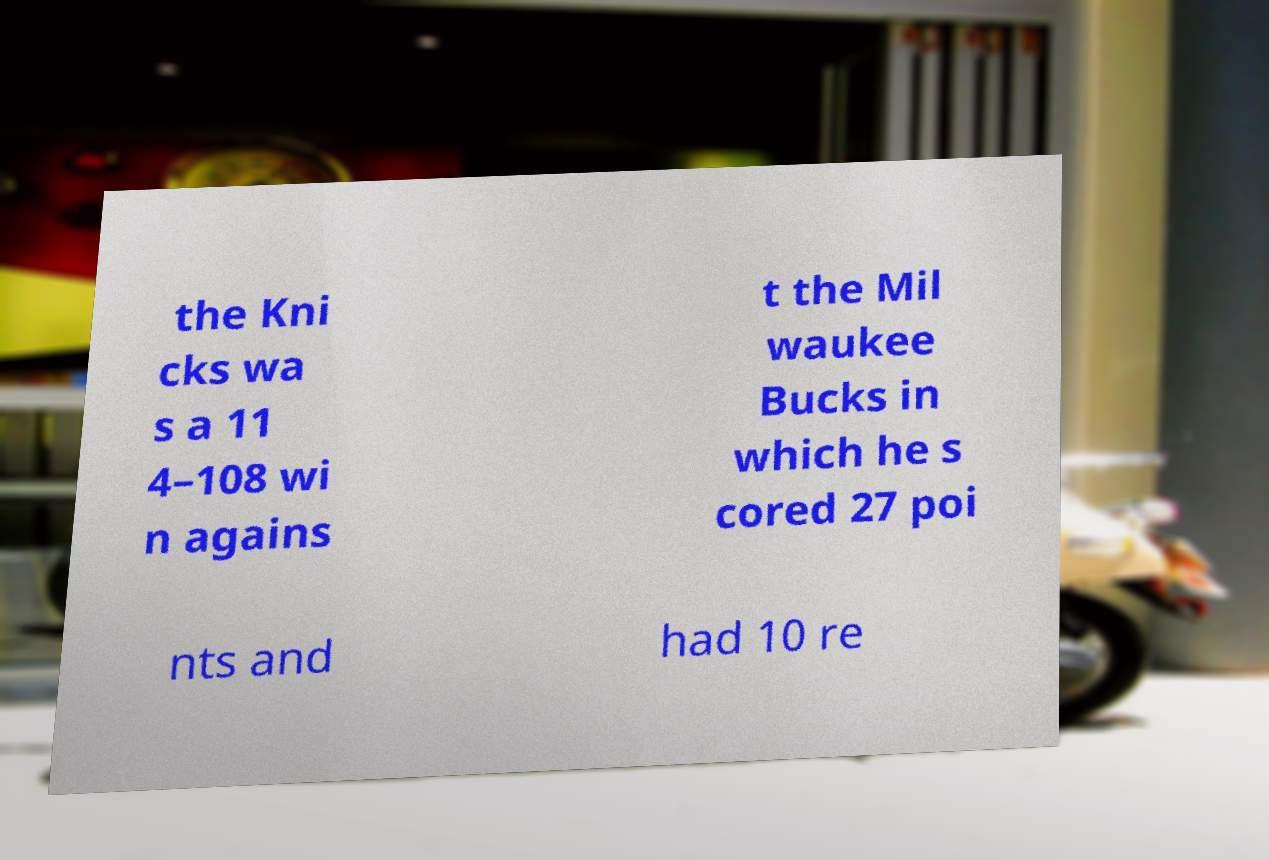Please read and relay the text visible in this image. What does it say? the Kni cks wa s a 11 4–108 wi n agains t the Mil waukee Bucks in which he s cored 27 poi nts and had 10 re 